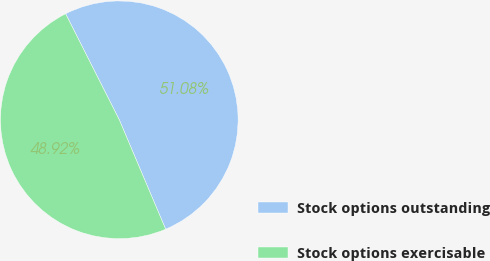<chart> <loc_0><loc_0><loc_500><loc_500><pie_chart><fcel>Stock options outstanding<fcel>Stock options exercisable<nl><fcel>51.08%<fcel>48.92%<nl></chart> 